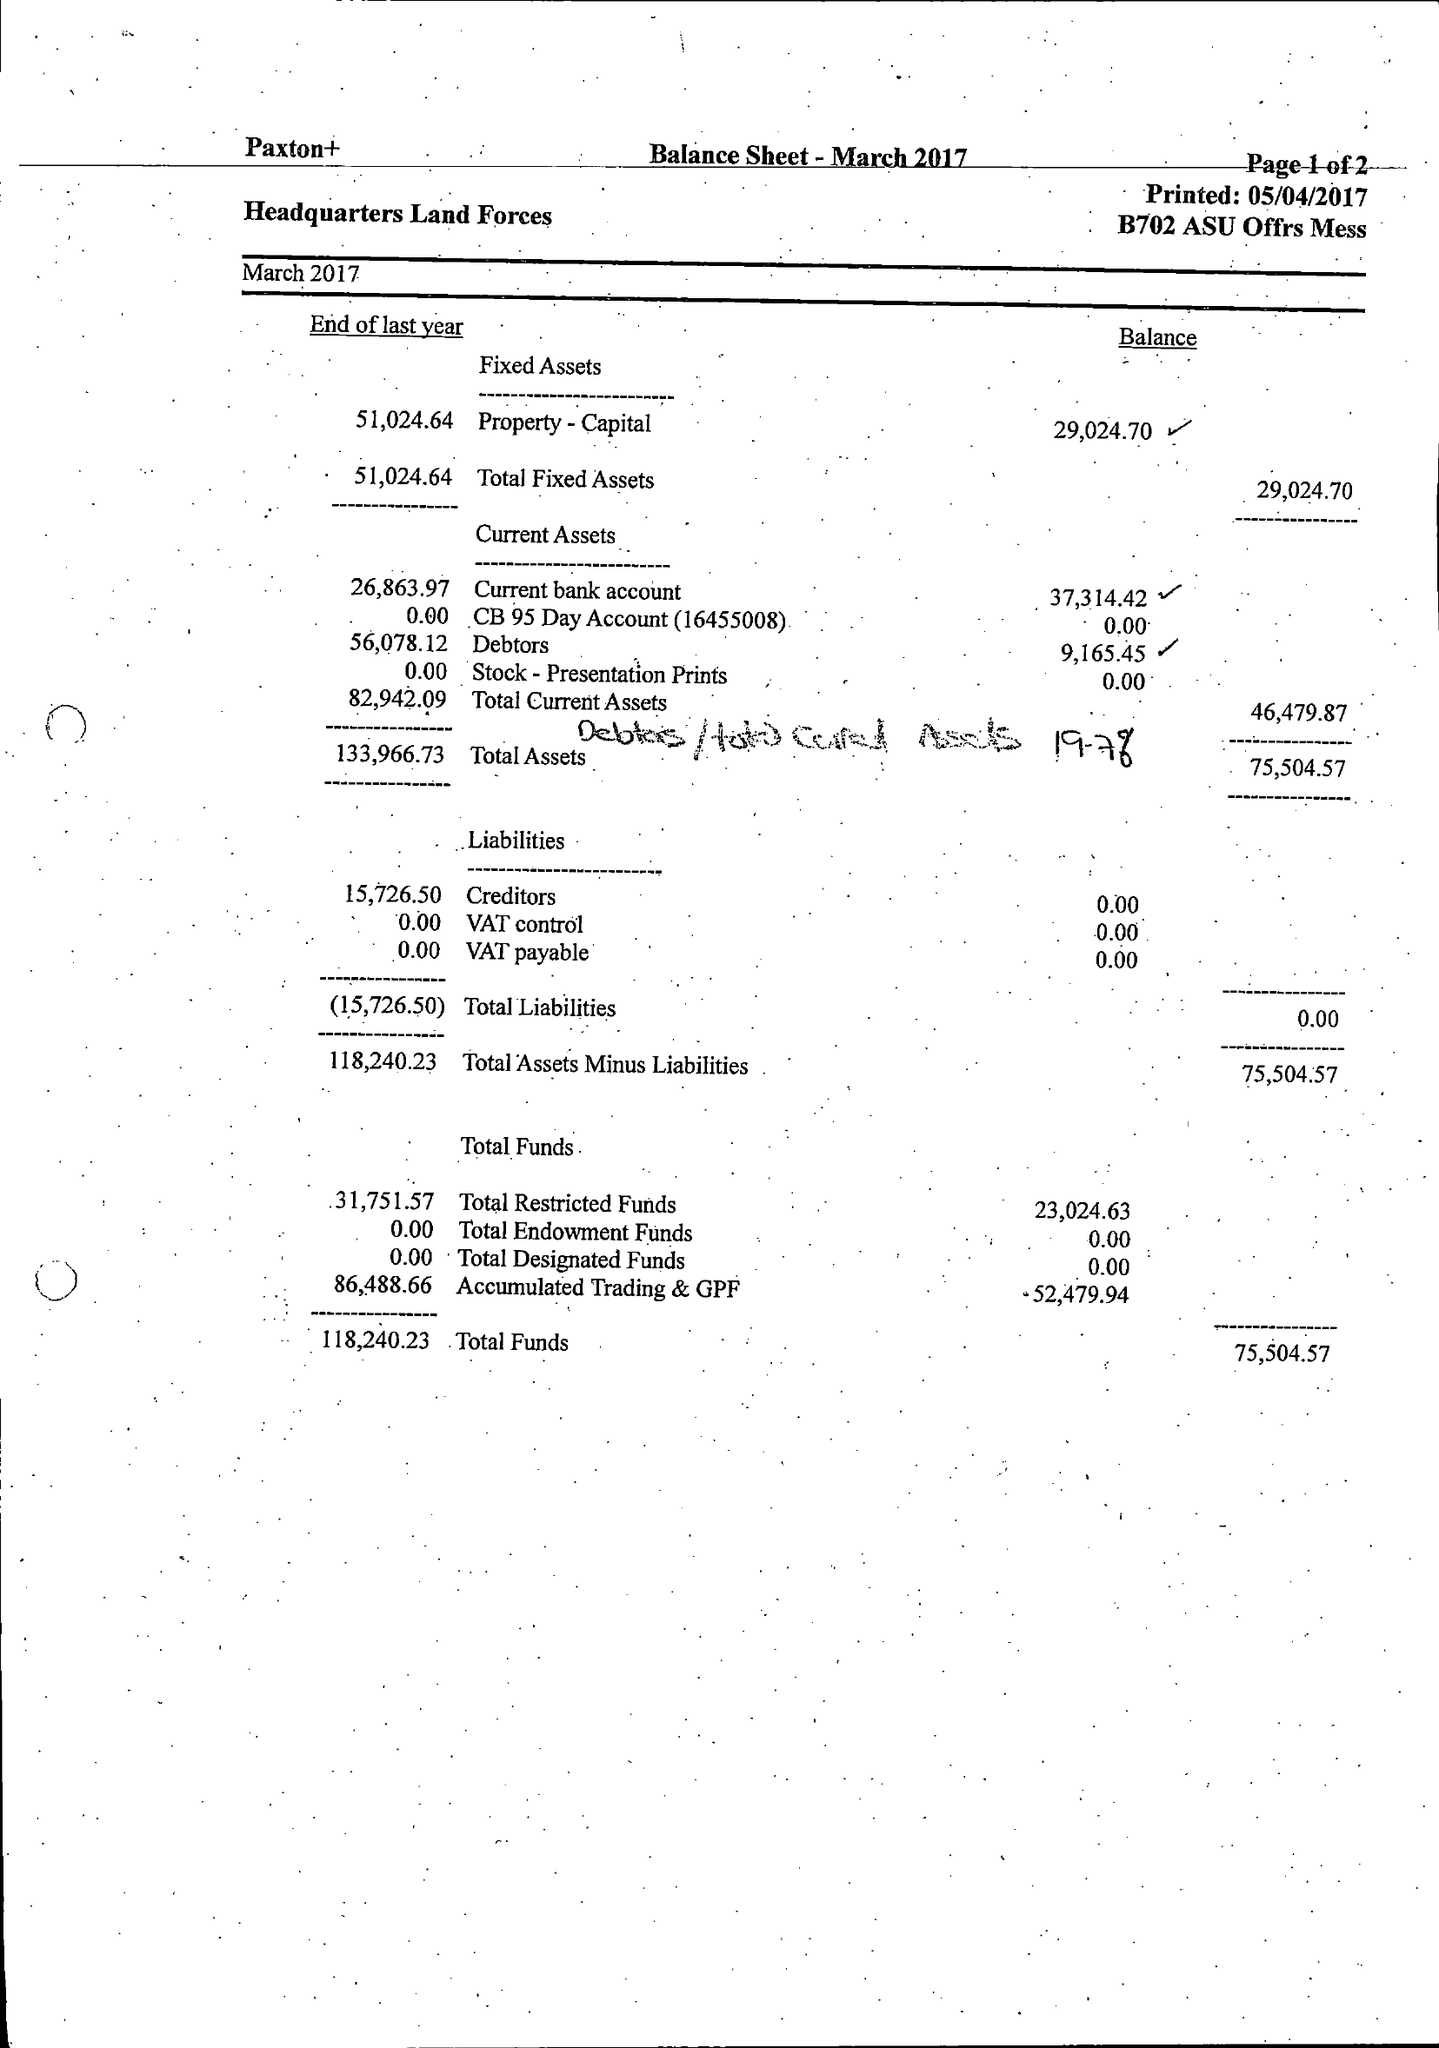What is the value for the address__postcode?
Answer the question using a single word or phrase. SP11 8HJ 